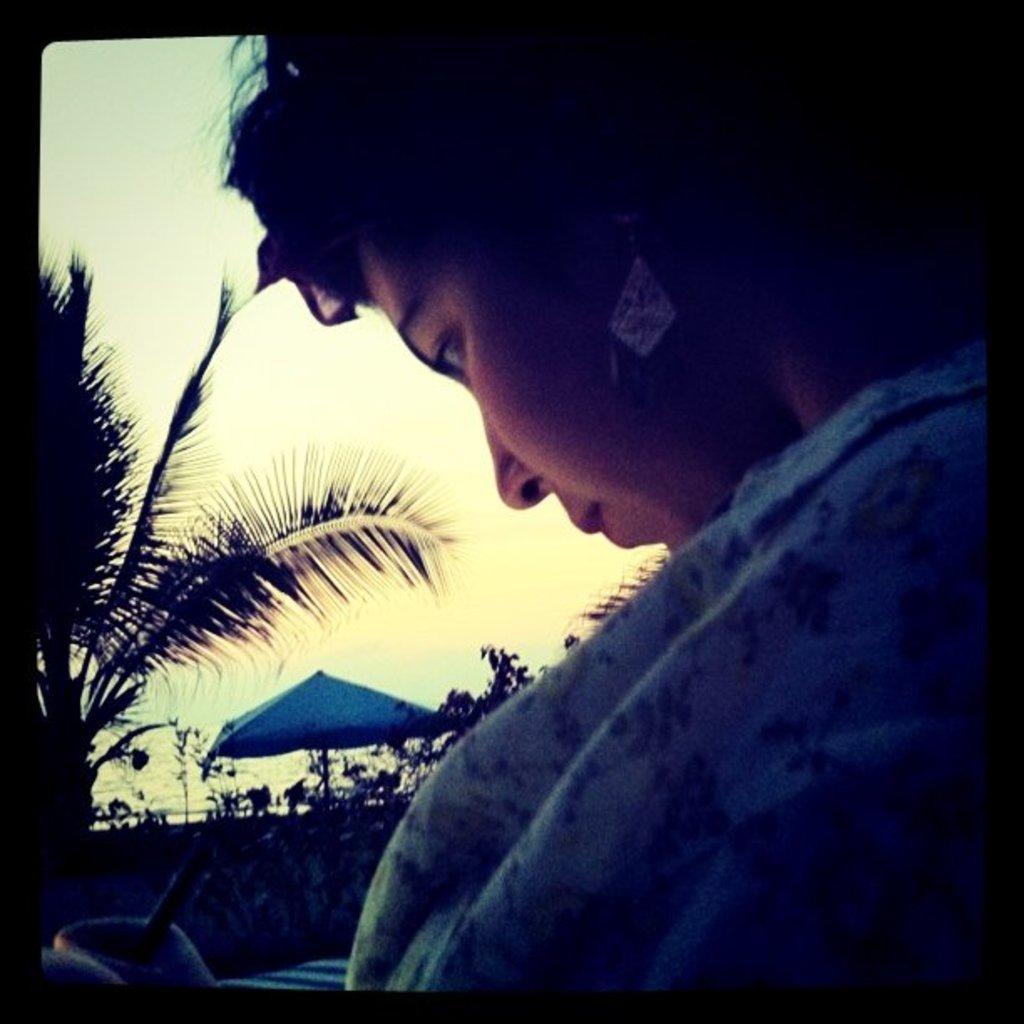Please provide a concise description of this image. In the background we can see the sky. In this picture we can see the plants and an umbrella. On the left side of the picture we can see a tree. This picture is mainly highlighted with a woman and it seems like she is holding a pen. 